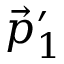<formula> <loc_0><loc_0><loc_500><loc_500>\vec { p } _ { 1 } ^ { \prime }</formula> 